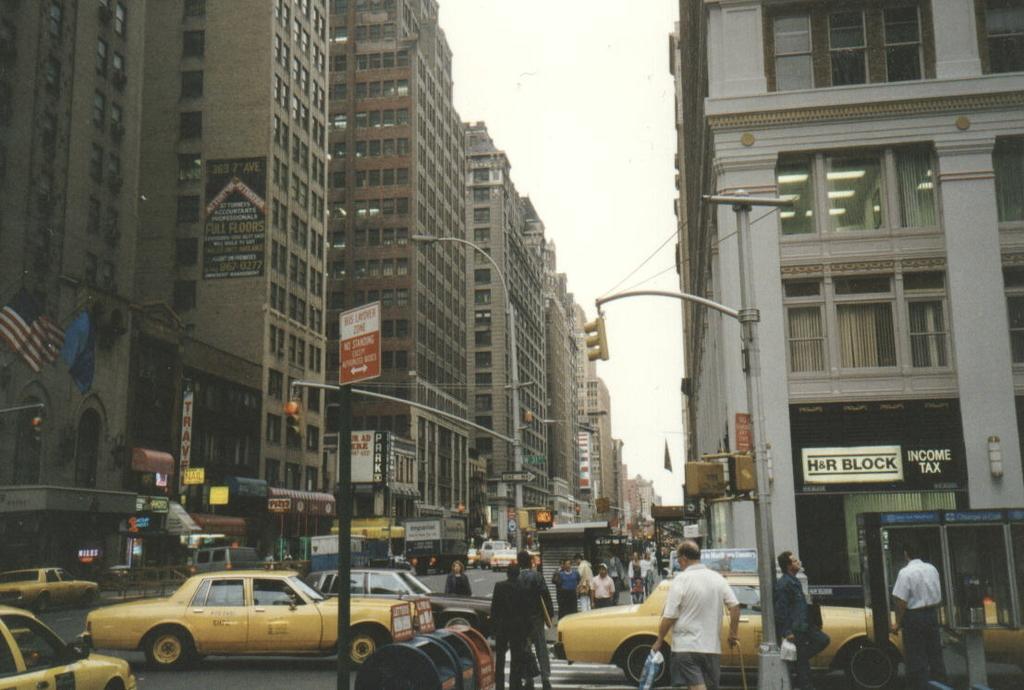How would you summarize this image in a sentence or two? In this image we can see cars and people are moving on the road. To the both sides of the road street lights, poles and buildings are present. The sky is in white color. Left side of the image flags are present. 